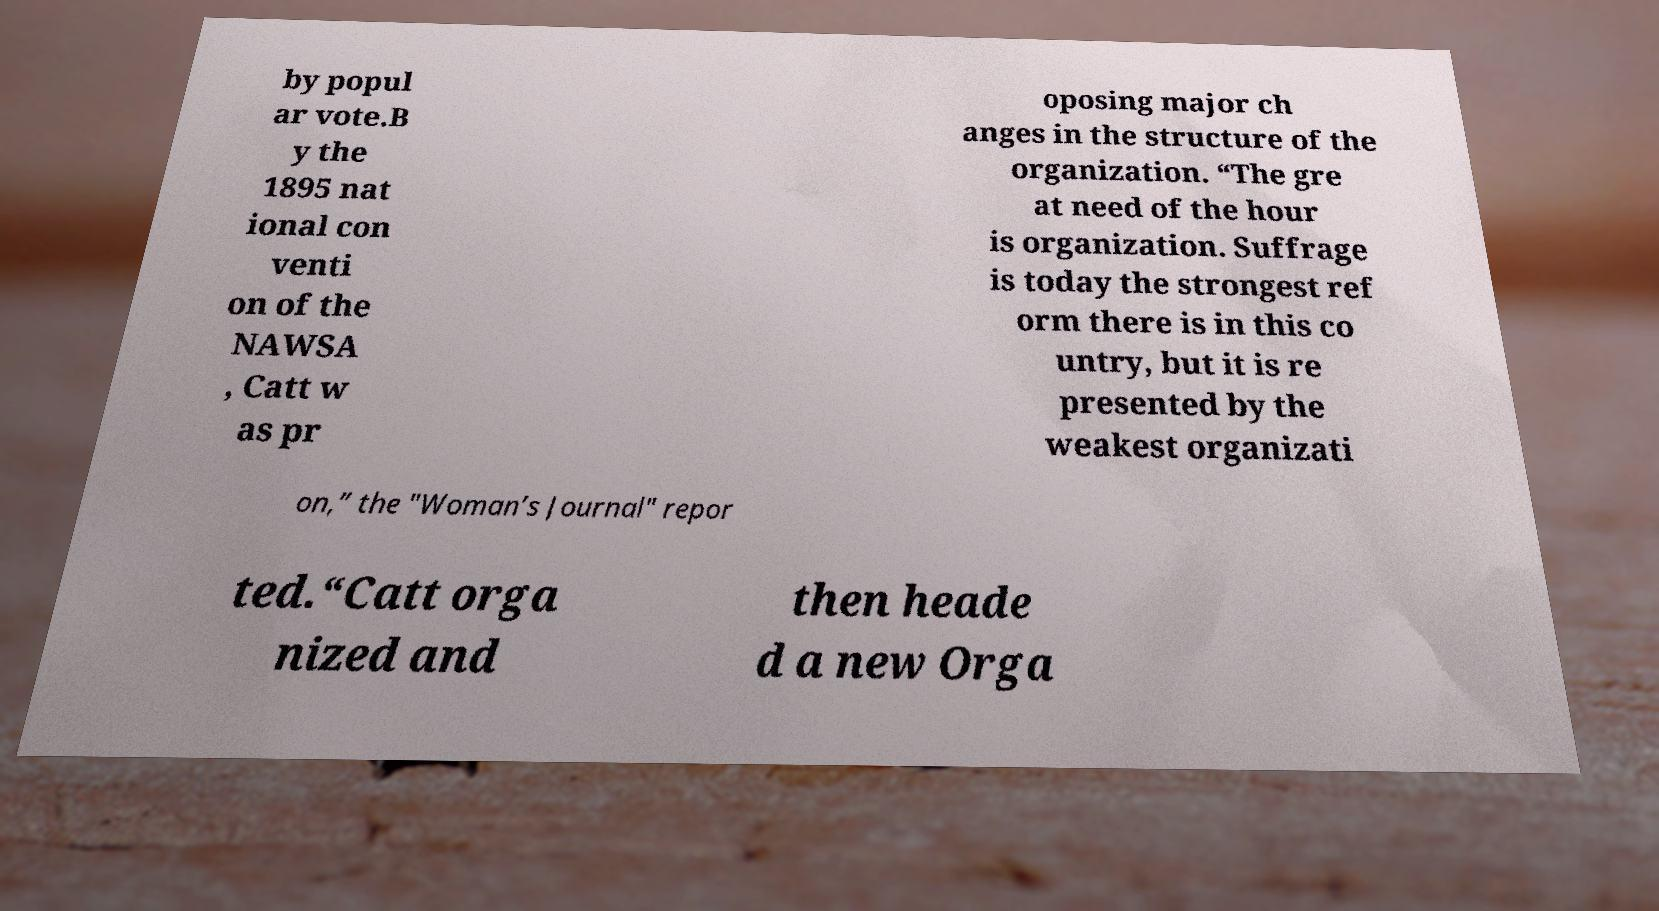There's text embedded in this image that I need extracted. Can you transcribe it verbatim? by popul ar vote.B y the 1895 nat ional con venti on of the NAWSA , Catt w as pr oposing major ch anges in the structure of the organization. “The gre at need of the hour is organization. Suffrage is today the strongest ref orm there is in this co untry, but it is re presented by the weakest organizati on,” the "Woman’s Journal" repor ted.“Catt orga nized and then heade d a new Orga 